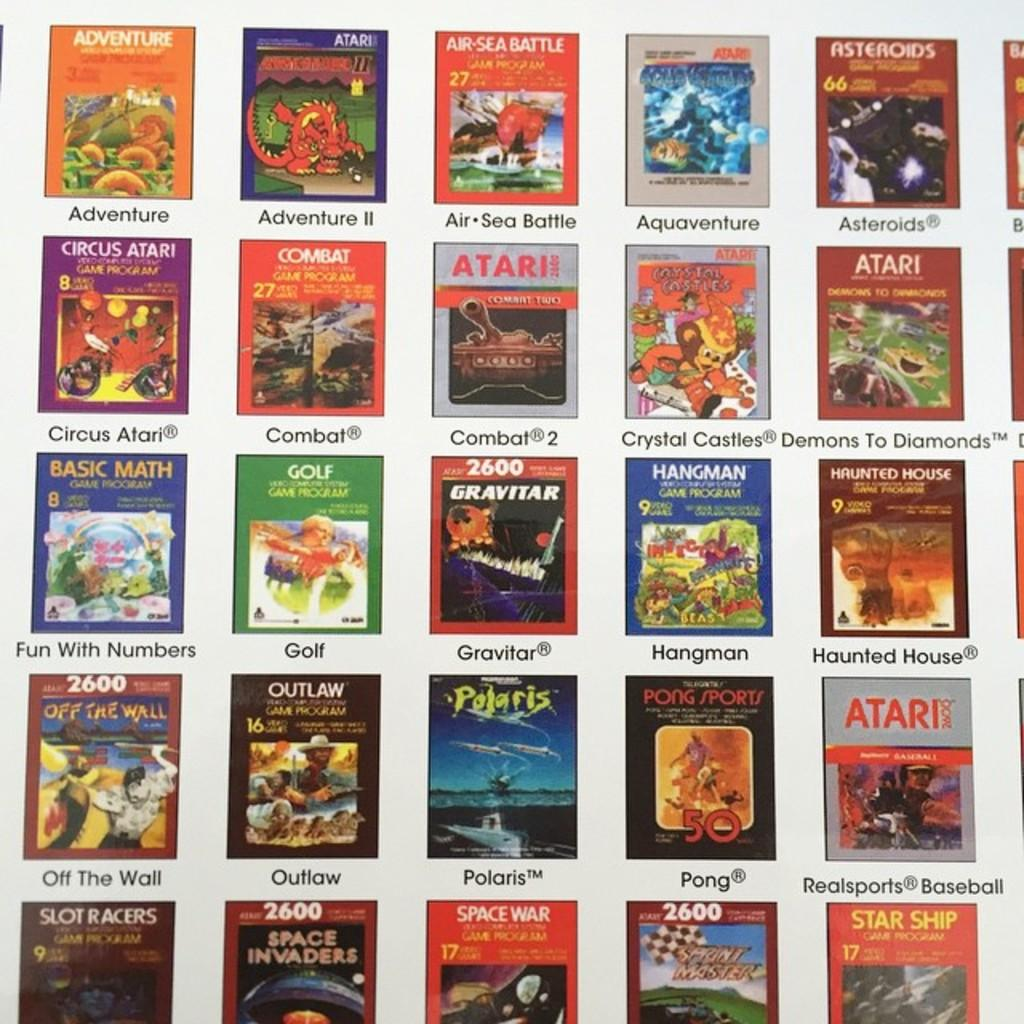<image>
Provide a brief description of the given image. Several books sit on display with one being about Basic Math Fun with Numbers 